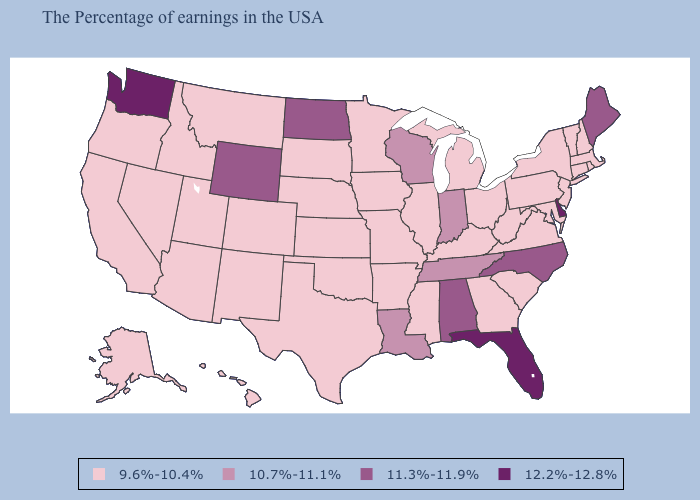Name the states that have a value in the range 10.7%-11.1%?
Keep it brief. Indiana, Tennessee, Wisconsin, Louisiana. Among the states that border Montana , does Wyoming have the highest value?
Write a very short answer. Yes. How many symbols are there in the legend?
Write a very short answer. 4. Does Iowa have a higher value than Michigan?
Short answer required. No. Name the states that have a value in the range 10.7%-11.1%?
Give a very brief answer. Indiana, Tennessee, Wisconsin, Louisiana. Does the first symbol in the legend represent the smallest category?
Answer briefly. Yes. What is the highest value in the South ?
Quick response, please. 12.2%-12.8%. Which states have the highest value in the USA?
Quick response, please. Delaware, Florida, Washington. Which states hav the highest value in the Northeast?
Answer briefly. Maine. Among the states that border Mississippi , does Alabama have the highest value?
Write a very short answer. Yes. Name the states that have a value in the range 12.2%-12.8%?
Short answer required. Delaware, Florida, Washington. Among the states that border Georgia , which have the lowest value?
Give a very brief answer. South Carolina. Is the legend a continuous bar?
Concise answer only. No. Name the states that have a value in the range 11.3%-11.9%?
Short answer required. Maine, North Carolina, Alabama, North Dakota, Wyoming. Among the states that border Massachusetts , which have the highest value?
Short answer required. Rhode Island, New Hampshire, Vermont, Connecticut, New York. 